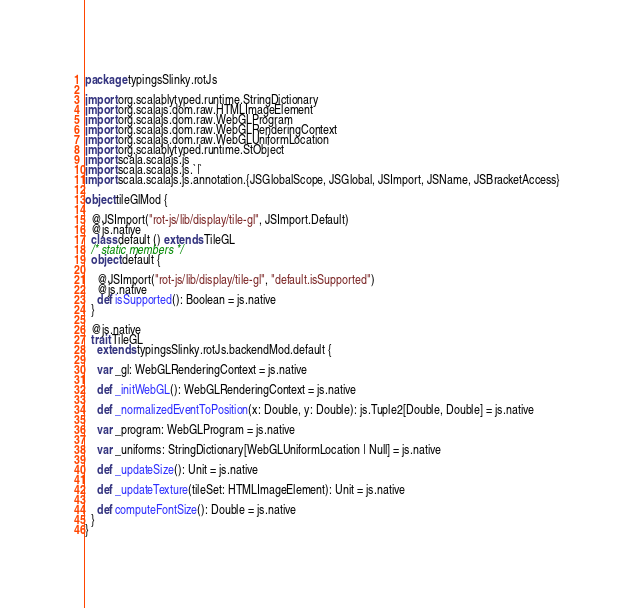<code> <loc_0><loc_0><loc_500><loc_500><_Scala_>package typingsSlinky.rotJs

import org.scalablytyped.runtime.StringDictionary
import org.scalajs.dom.raw.HTMLImageElement
import org.scalajs.dom.raw.WebGLProgram
import org.scalajs.dom.raw.WebGLRenderingContext
import org.scalajs.dom.raw.WebGLUniformLocation
import org.scalablytyped.runtime.StObject
import scala.scalajs.js
import scala.scalajs.js.`|`
import scala.scalajs.js.annotation.{JSGlobalScope, JSGlobal, JSImport, JSName, JSBracketAccess}

object tileGlMod {
  
  @JSImport("rot-js/lib/display/tile-gl", JSImport.Default)
  @js.native
  class default () extends TileGL
  /* static members */
  object default {
    
    @JSImport("rot-js/lib/display/tile-gl", "default.isSupported")
    @js.native
    def isSupported(): Boolean = js.native
  }
  
  @js.native
  trait TileGL
    extends typingsSlinky.rotJs.backendMod.default {
    
    var _gl: WebGLRenderingContext = js.native
    
    def _initWebGL(): WebGLRenderingContext = js.native
    
    def _normalizedEventToPosition(x: Double, y: Double): js.Tuple2[Double, Double] = js.native
    
    var _program: WebGLProgram = js.native
    
    var _uniforms: StringDictionary[WebGLUniformLocation | Null] = js.native
    
    def _updateSize(): Unit = js.native
    
    def _updateTexture(tileSet: HTMLImageElement): Unit = js.native
    
    def computeFontSize(): Double = js.native
  }
}
</code> 